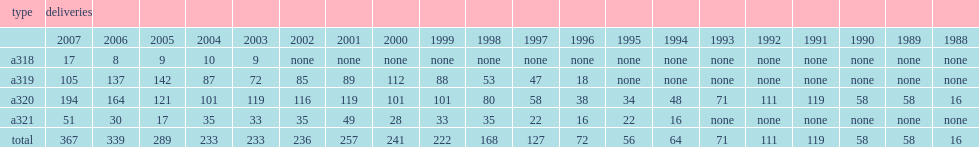When did the airbus a320 family deliver the a318 in the first place? 2003.0. 